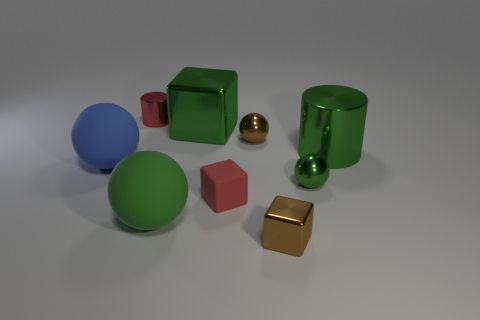Subtract 1 blocks. How many blocks are left? 2 Subtract all balls. How many objects are left? 5 Subtract 1 brown cubes. How many objects are left? 8 Subtract all large green balls. Subtract all red cylinders. How many objects are left? 7 Add 7 brown metal spheres. How many brown metal spheres are left? 8 Add 5 yellow metallic spheres. How many yellow metallic spheres exist? 5 